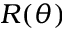Convert formula to latex. <formula><loc_0><loc_0><loc_500><loc_500>R ( \theta )</formula> 